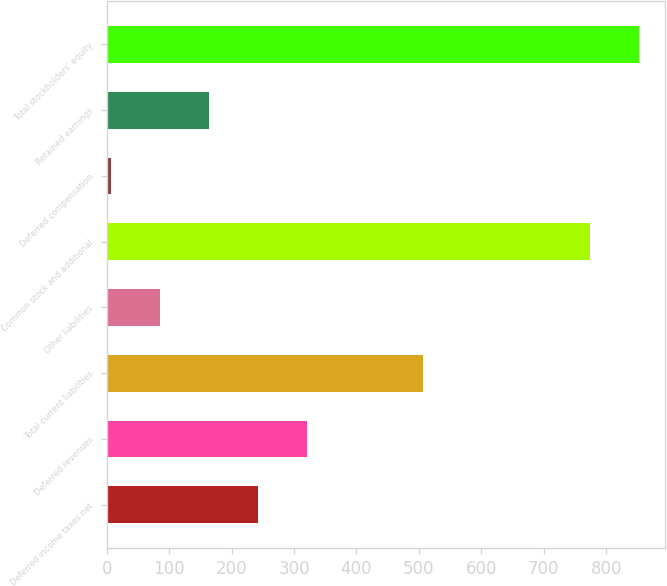Convert chart. <chart><loc_0><loc_0><loc_500><loc_500><bar_chart><fcel>Deferred income taxes net<fcel>Deferred revenues<fcel>Total current liabilities<fcel>Other liabilities<fcel>Common stock and additional<fcel>Deferred compensation<fcel>Retained earnings<fcel>Total stockholders' equity<nl><fcel>241.66<fcel>320.18<fcel>506.9<fcel>84.62<fcel>773.7<fcel>6.1<fcel>163.14<fcel>852.22<nl></chart> 